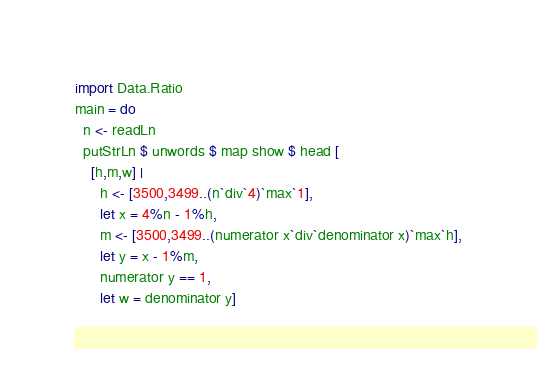<code> <loc_0><loc_0><loc_500><loc_500><_Haskell_>import Data.Ratio
main = do
  n <- readLn
  putStrLn $ unwords $ map show $ head [
    [h,m,w] |
      h <- [3500,3499..(n`div`4)`max`1],
      let x = 4%n - 1%h,
      m <- [3500,3499..(numerator x`div`denominator x)`max`h],
      let y = x - 1%m,
      numerator y == 1,
      let w = denominator y]
</code> 